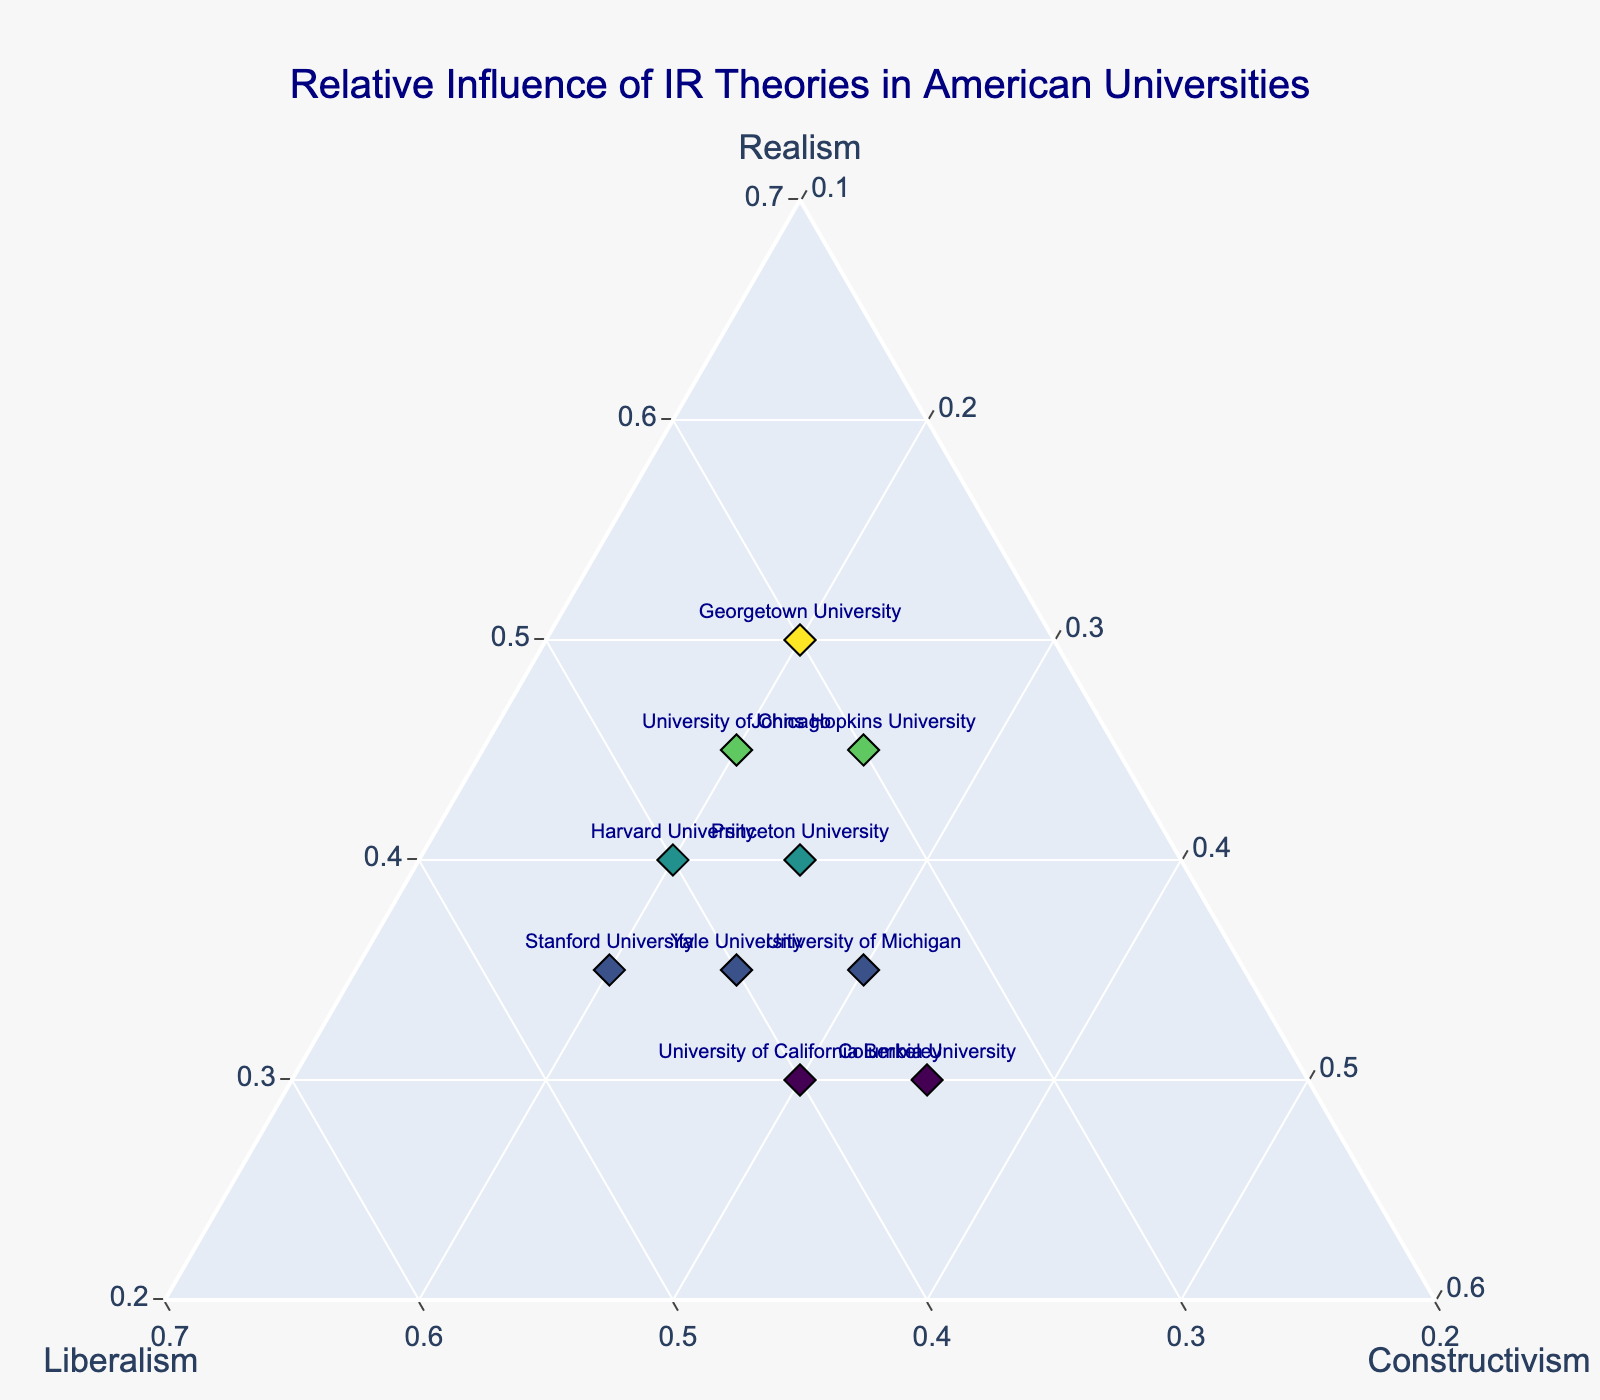What's the title of the figure? The figure has a title text at the top. It reads, "Relative Influence of IR Theories in American Universities."
Answer: Relative Influence of IR Theories in American Universities How many data points represent the universities? Each university is represented by a marker on the plot. Counting the markers, we find there are 10 universities plotted.
Answer: 10 Which university has the highest influence of realism? Look for the university whose marker is positioned closest to the 'Realism' corner of the ternary plot. Georgetown University, at 0.50, has the highest Realism influence.
Answer: Georgetown University What is the influence of constructivism at Columbia University? Locate the marker for Columbia University and read the percentage of Constructivism influence, which is represented on the axis labeled 'Constructivism.' It’s 0.35.
Answer: 0.35 Which university has an equal influence of Realism and Liberalism? Find the marker at the point where the Realism and Liberalism values are the same. Harvard University has Realism and Liberalism both at 0.40.
Answer: Harvard University Compare the influence of Liberalism between Stanford University and University of California Berkeley. Which one is higher? Locate the marker for both universities and compare their Liberalism values. Stanford University has 0.45 and University of California Berkeley has 0.40.
Answer: Stanford University What is the combined influence of Realism and Liberalism at Princeton University? Sum the percentages of Realism and Liberalism for Princeton University, which has 0.40 for Realism and 0.35 for Liberalism. The total is 0.40 + 0.35 = 0.75.
Answer: 0.75 Which theory has the smallest minimum value across all universities, and what is that value? Examine the plot to find the smallest value for each theory (Realism, Liberalism, and Constructivism). The smallest minimum value is 0.20, seen in Constructivism at multiple universities.
Answer: Constructivism, 0.20 For Columbia University, is the influence of Liberalism greater than that of Realism? Compare the values for Liberalism and Realism for Columbia University. Liberalism is 0.35 and Realism is 0.30, so Liberalism is greater.
Answer: Yes Which university shows an equal influence of Constructivism to Realism? Locate the marker for the university with equal values for Realism and Constructivism. None of the universities have equal values for Realism and Constructivism.
Answer: None 